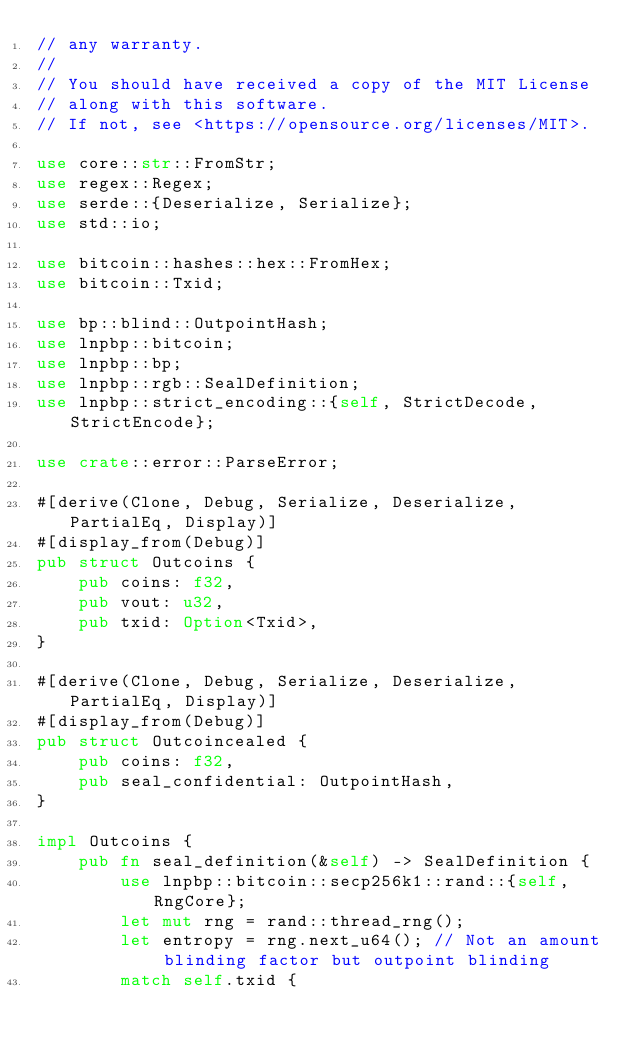<code> <loc_0><loc_0><loc_500><loc_500><_Rust_>// any warranty.
//
// You should have received a copy of the MIT License
// along with this software.
// If not, see <https://opensource.org/licenses/MIT>.

use core::str::FromStr;
use regex::Regex;
use serde::{Deserialize, Serialize};
use std::io;

use bitcoin::hashes::hex::FromHex;
use bitcoin::Txid;

use bp::blind::OutpointHash;
use lnpbp::bitcoin;
use lnpbp::bp;
use lnpbp::rgb::SealDefinition;
use lnpbp::strict_encoding::{self, StrictDecode, StrictEncode};

use crate::error::ParseError;

#[derive(Clone, Debug, Serialize, Deserialize, PartialEq, Display)]
#[display_from(Debug)]
pub struct Outcoins {
    pub coins: f32,
    pub vout: u32,
    pub txid: Option<Txid>,
}

#[derive(Clone, Debug, Serialize, Deserialize, PartialEq, Display)]
#[display_from(Debug)]
pub struct Outcoincealed {
    pub coins: f32,
    pub seal_confidential: OutpointHash,
}

impl Outcoins {
    pub fn seal_definition(&self) -> SealDefinition {
        use lnpbp::bitcoin::secp256k1::rand::{self, RngCore};
        let mut rng = rand::thread_rng();
        let entropy = rng.next_u64(); // Not an amount blinding factor but outpoint blinding
        match self.txid {</code> 